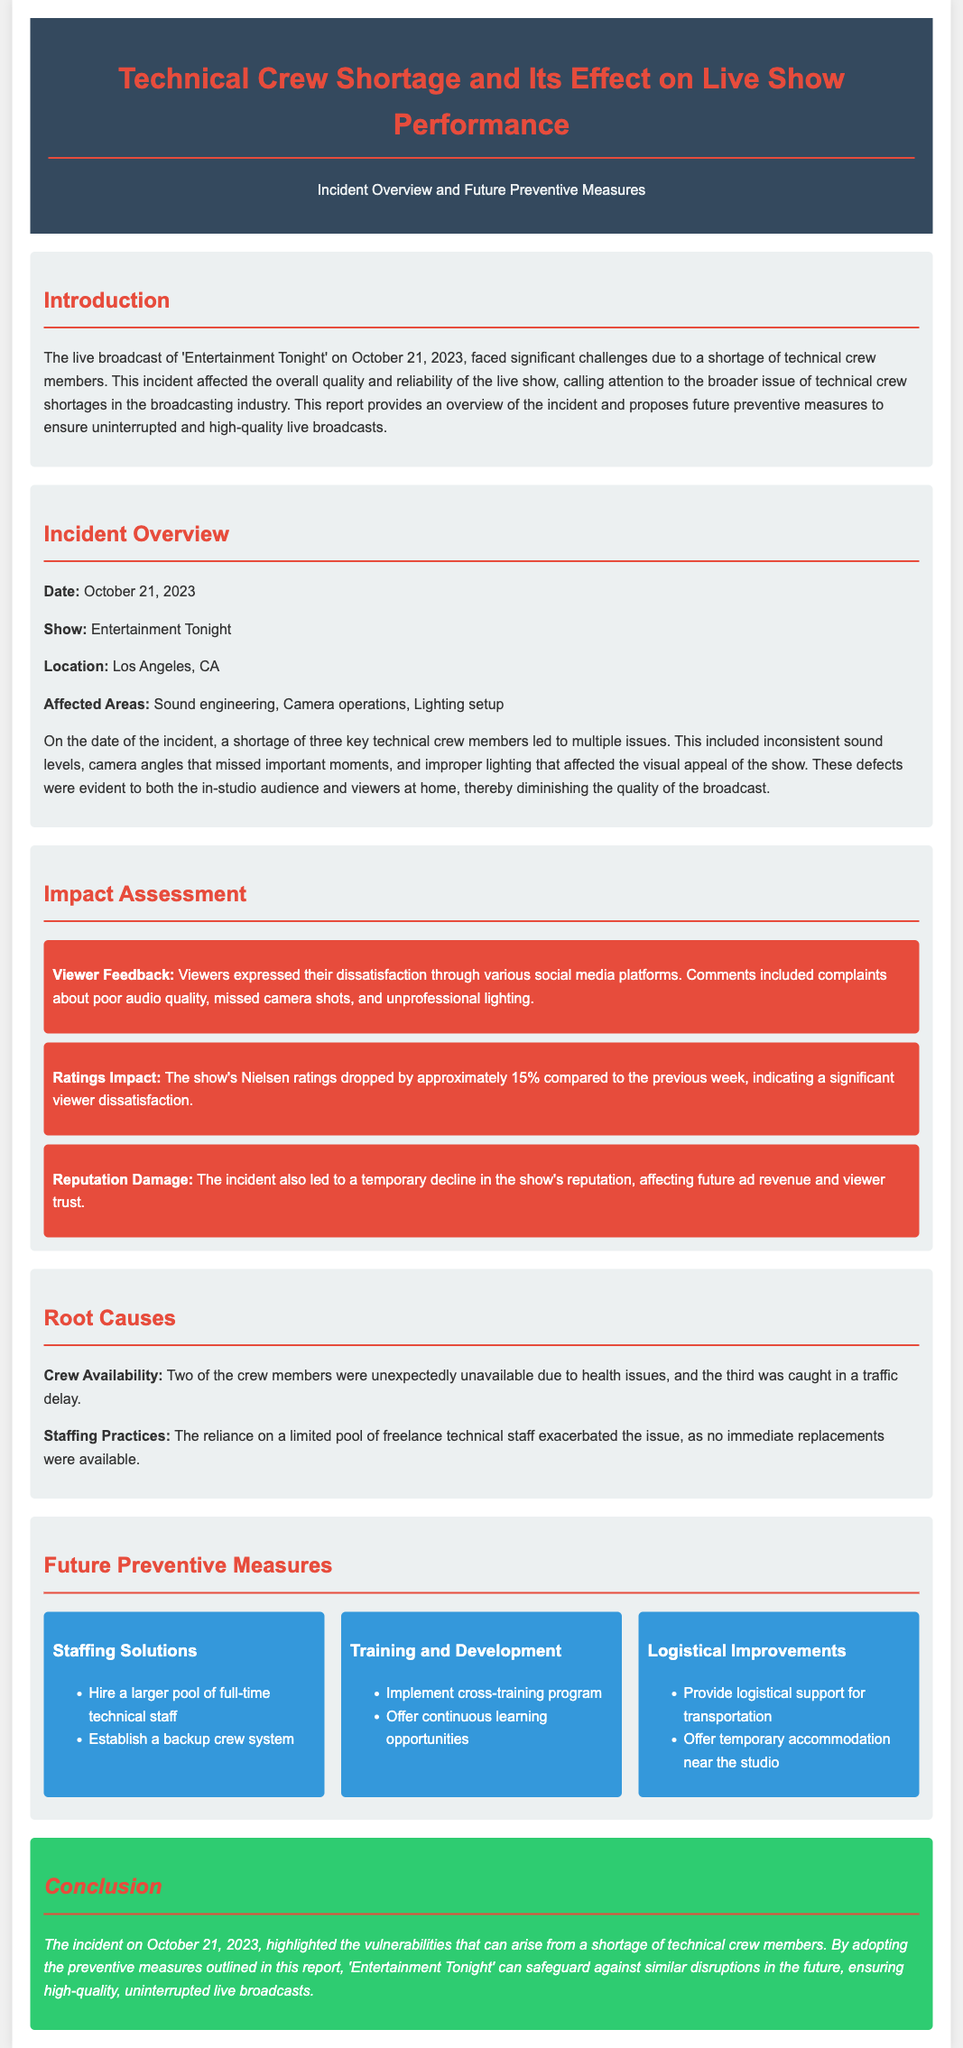What was the date of the incident? The date of the incident is clearly stated in the document as October 21, 2023.
Answer: October 21, 2023 Which show was affected by the technical crew shortage? The affected show is specifically mentioned in the document as 'Entertainment Tonight'.
Answer: Entertainment Tonight How many key technical crew members were short? The document specifies that three key technical crew members were short during the incident.
Answer: three What was the percentage drop in Nielsen ratings? The document mentions that the show's Nielsen ratings dropped by approximately 15% compared to the previous week.
Answer: 15% What are the root causes of the crew shortage? The document lists `Crew Availability` and `Staffing Practices` as the root causes of the technical crew shortage.
Answer: Crew Availability and Staffing Practices What measure involves hiring more staff? The measure that involves hiring more staff is listed under `Staffing Solutions`.
Answer: Staffing Solutions What issue did viewers express dissatisfaction about? The document states that viewers expressed dissatisfaction regarding poor audio quality, missed camera shots, and unprofessional lighting.
Answer: poor audio quality, missed camera shots, and unprofessional lighting What is a preventive measure suggested for transportation? The document suggests providing logistical support for transportation as a preventive measure.
Answer: logistical support for transportation What was one effect of the incident on the show's reputation? The document states that the incident led to a temporary decline in the show's reputation.
Answer: temporary decline in the show's reputation 